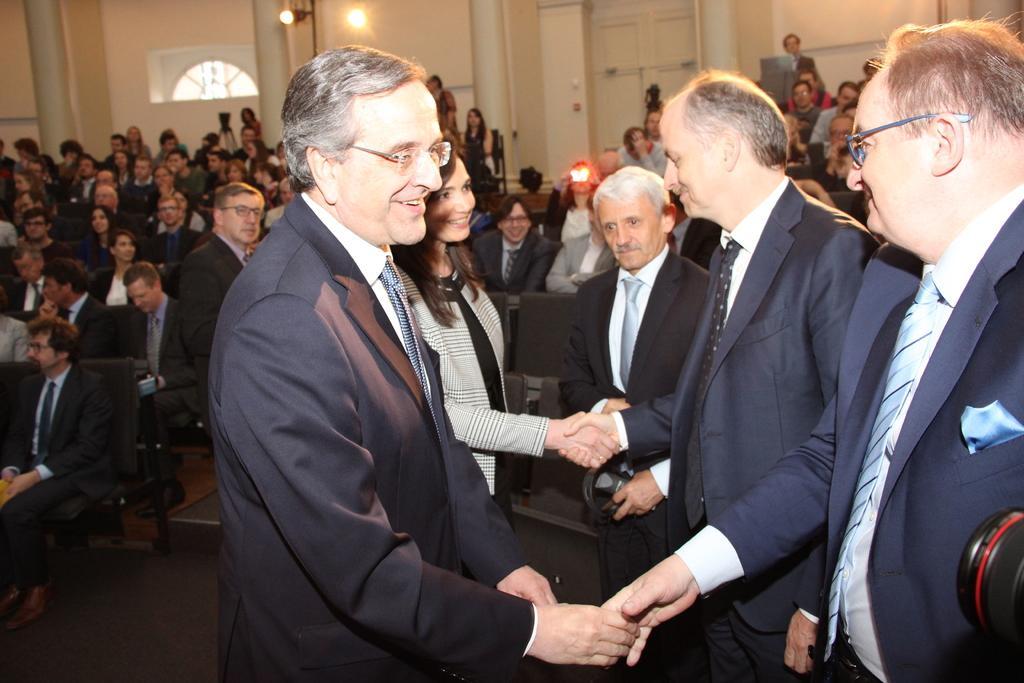Describe this image in one or two sentences. In this image, we can see a group of people are standing. Few are smiling. Here we can see few people are shaking their hands with each other. Background we can see chairs, people, walls, pillars, lights, doors and few things. 